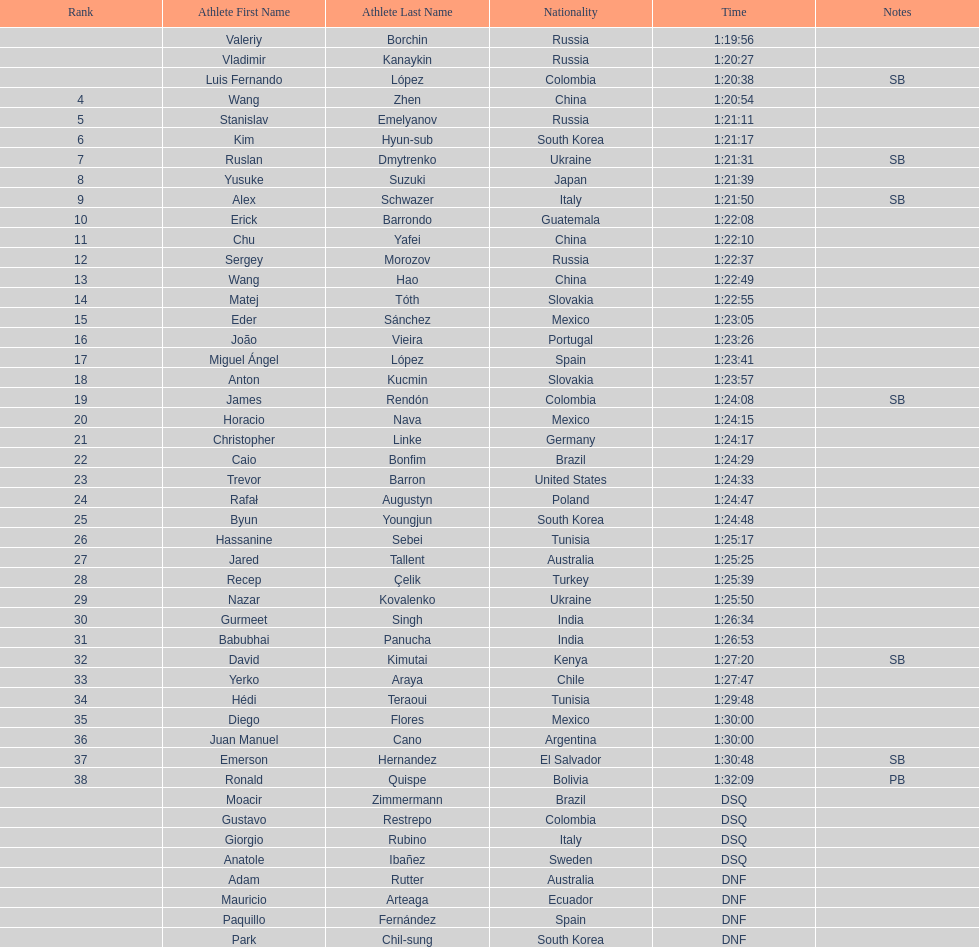Which athlete had the fastest time for the 20km? Valeriy Borchin. 